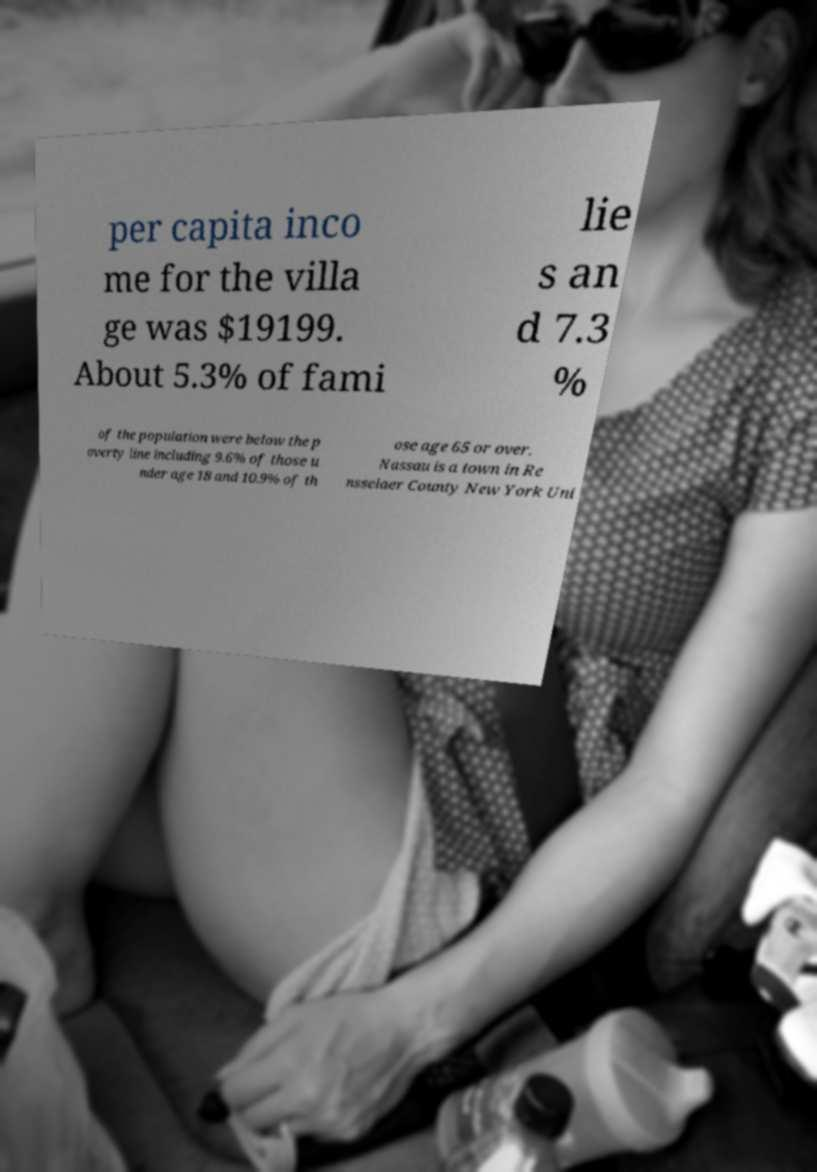What messages or text are displayed in this image? I need them in a readable, typed format. per capita inco me for the villa ge was $19199. About 5.3% of fami lie s an d 7.3 % of the population were below the p overty line including 9.6% of those u nder age 18 and 10.9% of th ose age 65 or over. Nassau is a town in Re nsselaer County New York Uni 